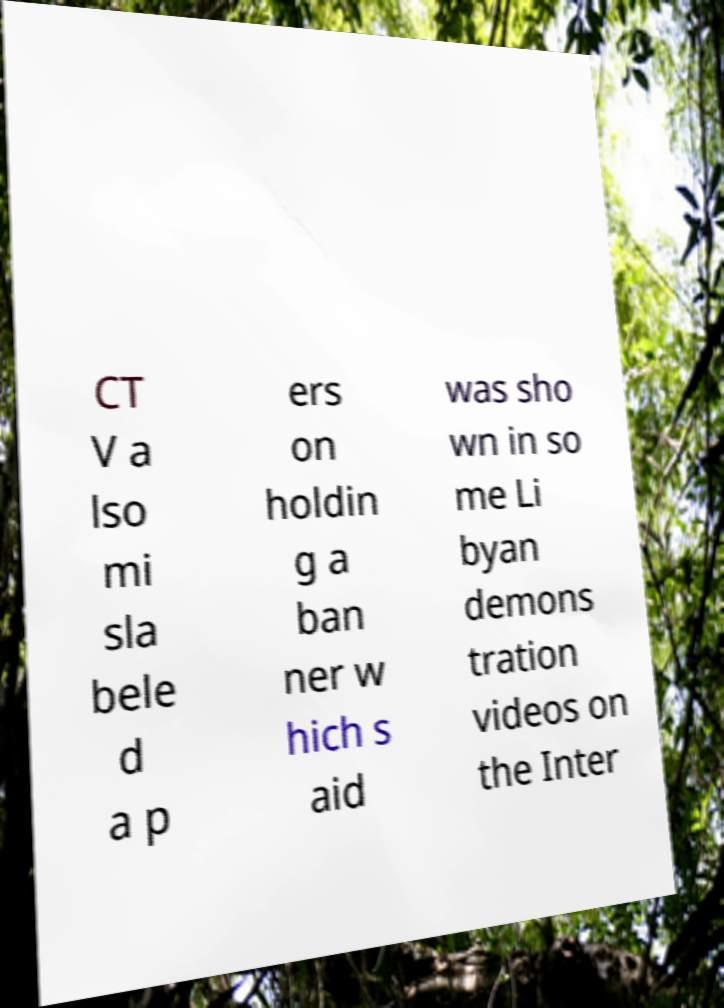For documentation purposes, I need the text within this image transcribed. Could you provide that? CT V a lso mi sla bele d a p ers on holdin g a ban ner w hich s aid was sho wn in so me Li byan demons tration videos on the Inter 